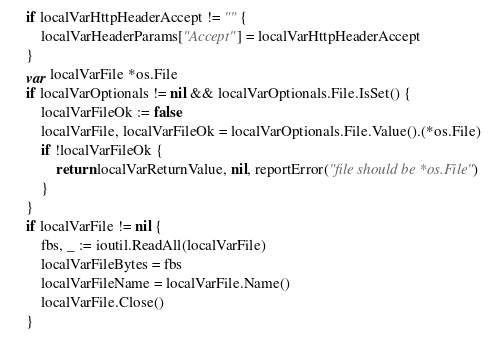Convert code to text. <code><loc_0><loc_0><loc_500><loc_500><_Go_>	if localVarHttpHeaderAccept != "" {
		localVarHeaderParams["Accept"] = localVarHttpHeaderAccept
	}
	var localVarFile *os.File
	if localVarOptionals != nil && localVarOptionals.File.IsSet() {
		localVarFileOk := false
		localVarFile, localVarFileOk = localVarOptionals.File.Value().(*os.File)
		if !localVarFileOk {
			return localVarReturnValue, nil, reportError("file should be *os.File")
		}
	}
	if localVarFile != nil {
		fbs, _ := ioutil.ReadAll(localVarFile)
		localVarFileBytes = fbs
		localVarFileName = localVarFile.Name()
		localVarFile.Close()
	}</code> 